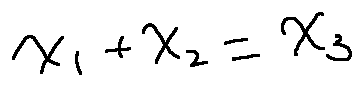<formula> <loc_0><loc_0><loc_500><loc_500>x _ { 1 } + x _ { 2 } = x _ { 3 }</formula> 